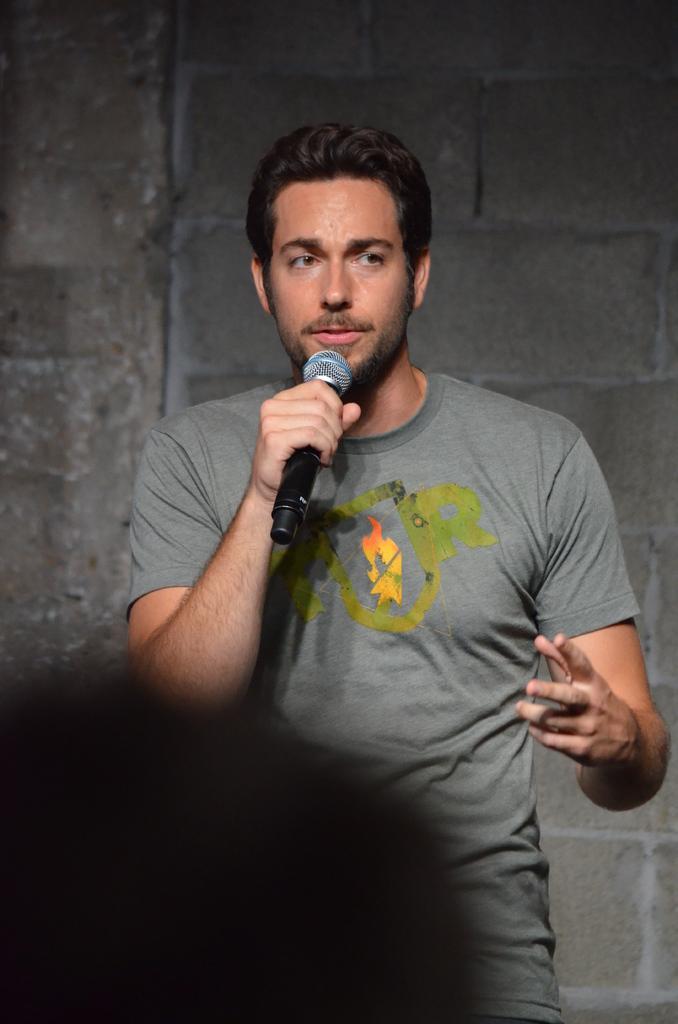How would you summarize this image in a sentence or two? In this image I can see a person standing. He is wearing the grey color t-shirt and he is holding the mic. In the back there is a grey color wall and I can see some shadow here. 